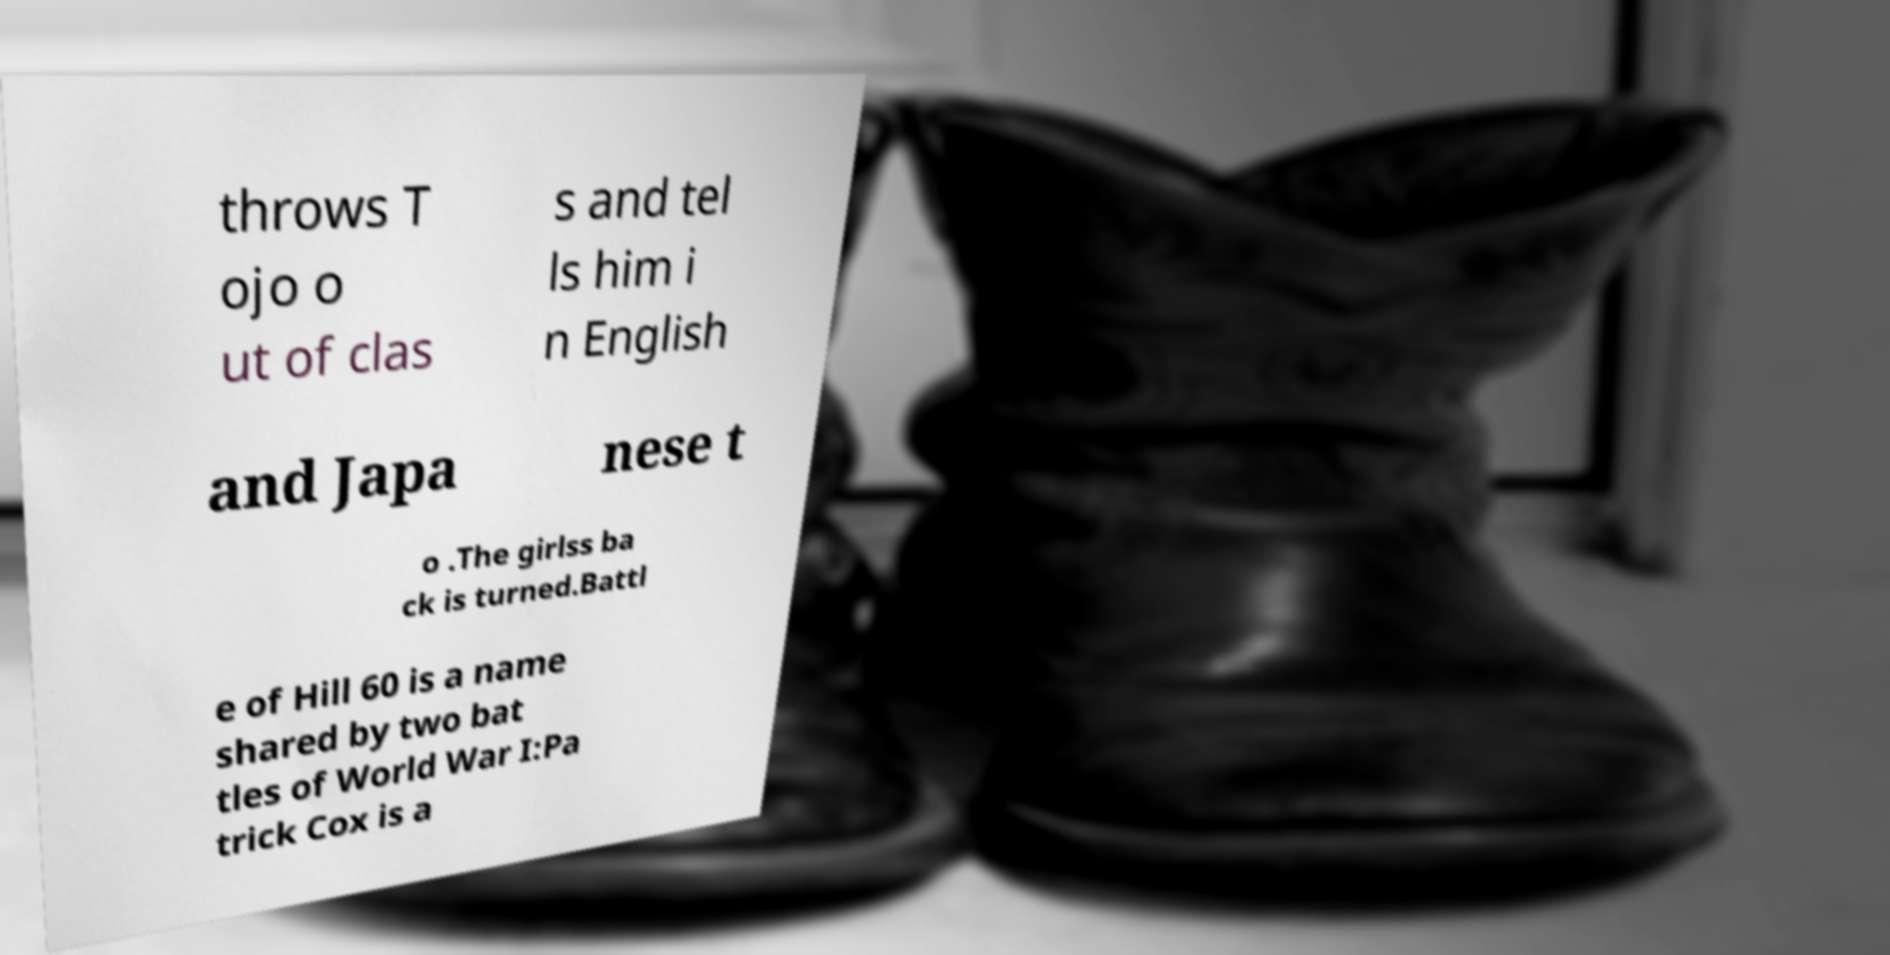What messages or text are displayed in this image? I need them in a readable, typed format. throws T ojo o ut of clas s and tel ls him i n English and Japa nese t o .The girlss ba ck is turned.Battl e of Hill 60 is a name shared by two bat tles of World War I:Pa trick Cox is a 